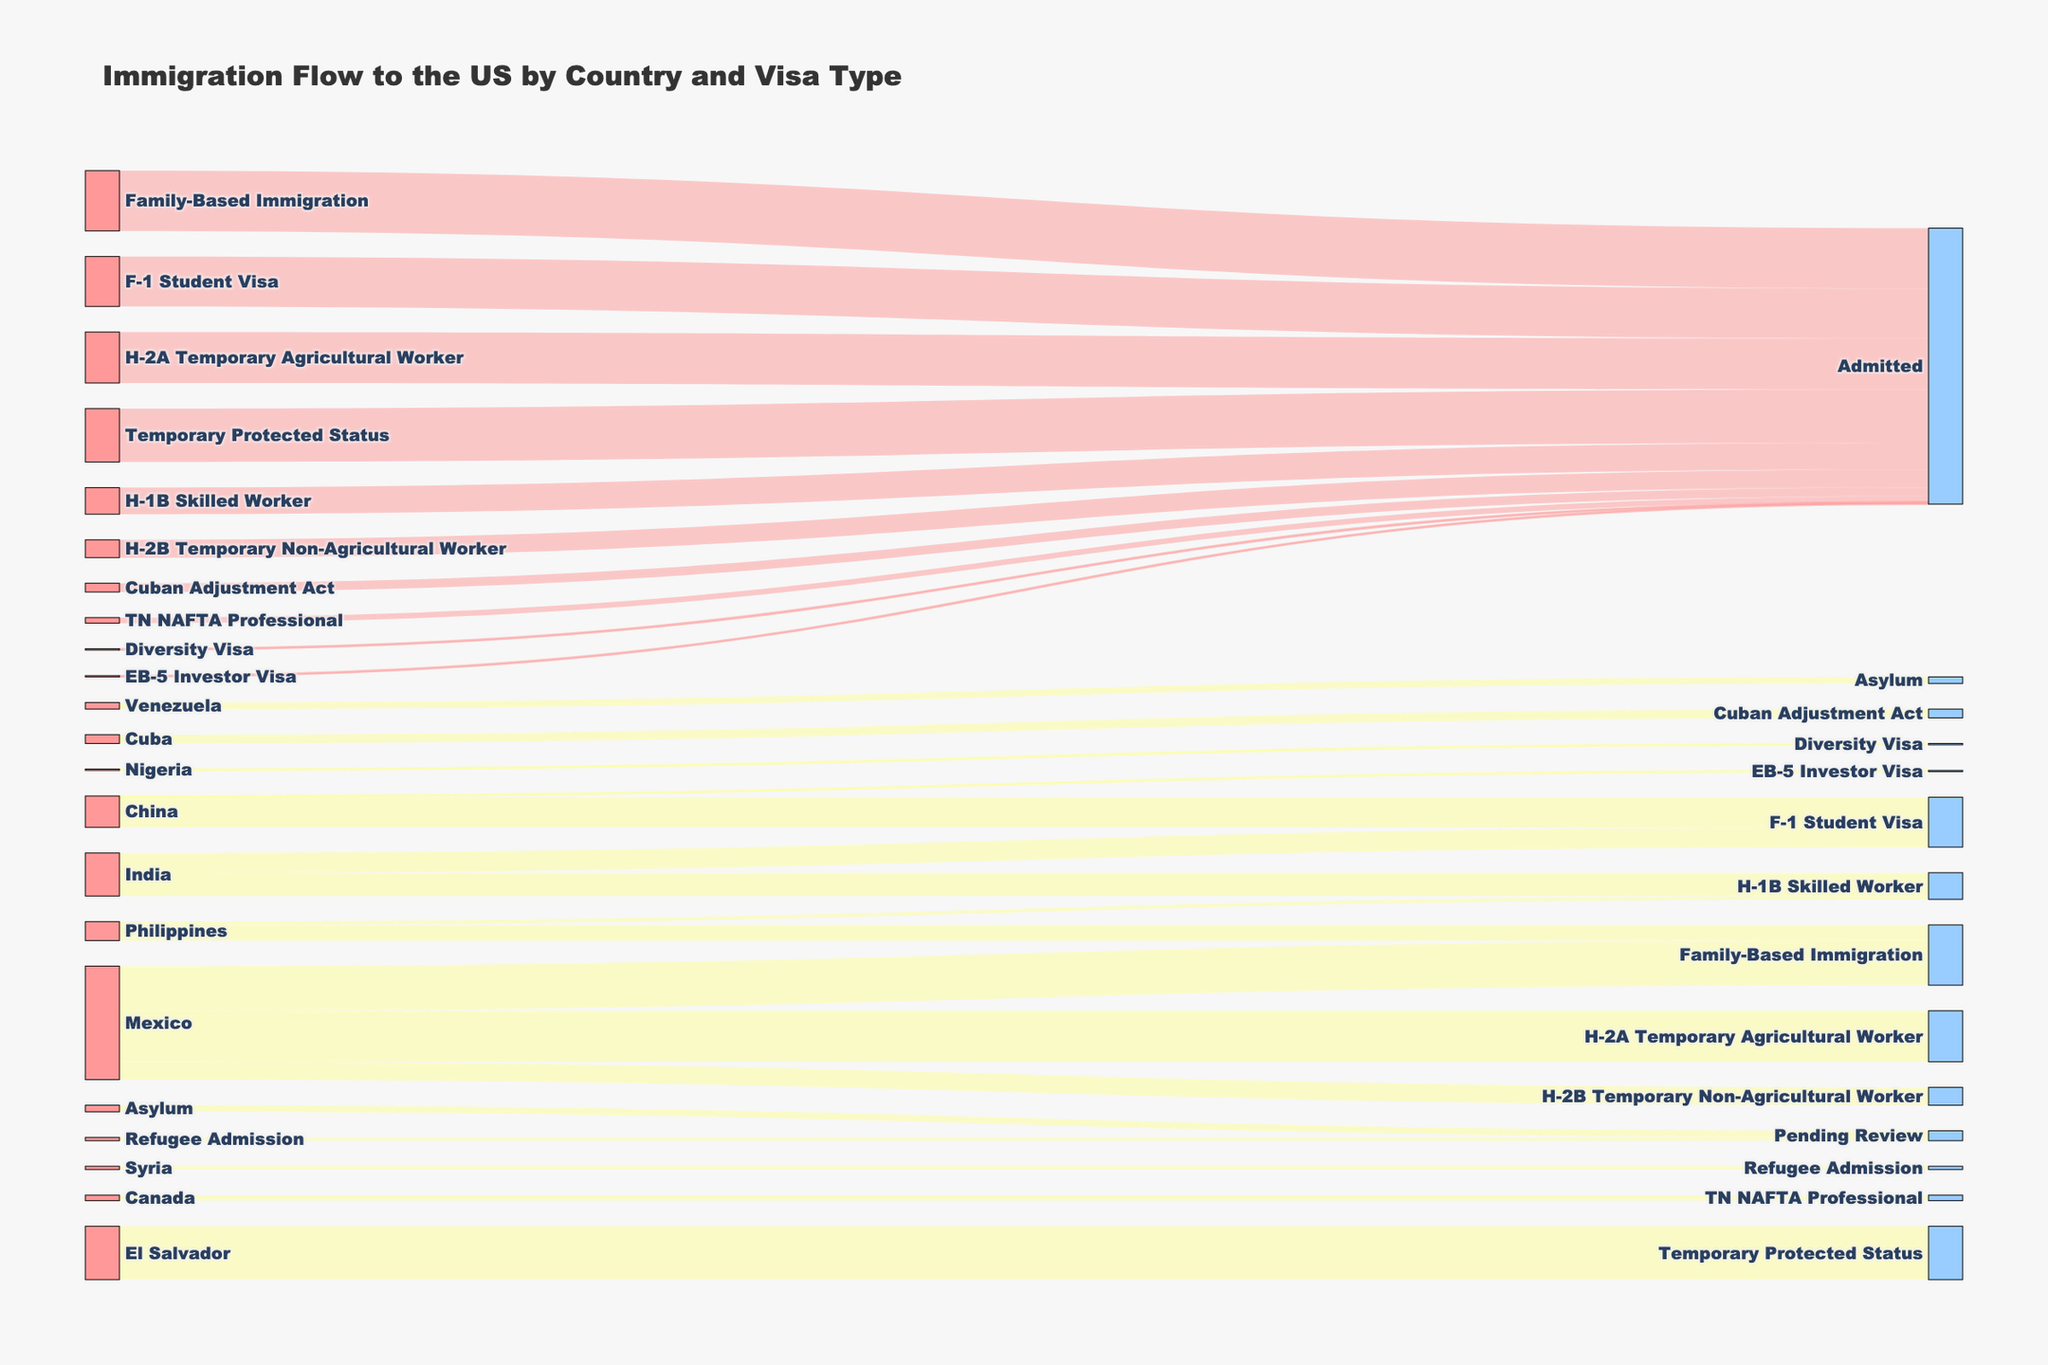What's the title of the figure? The title is usually displayed at the top of the figure. It provides a quick summary of what the chart represents.
Answer: Immigration Flow to the US by Country and Visa Type Which country has the highest number of H-2A Temporary Agricultural Worker visas? Look for the "H-2A Temporary Agricultural Worker" label and trace back to the country with the largest flow value associated with it.
Answer: Mexico From which country does Family-Based Immigration contribute the most? Find the "Family-Based Immigration" label, and check the originating flows to see which country has the highest number.
Answer: Mexico Compare the number of H-2B Temporary Non-Agricultural Worker visas from Mexico and the number of F-1 Student Visas from China. Which is higher? Find the values associated with "H-2B Temporary Non-Agricultural Worker" from Mexico and "F-1 Student Visa" from China, then compare them.
Answer: F-1 Student Visa from China What is the total number of admissions for all visa types combined? Sum all the values directed towards the "Admitted" nodes. These include H-2A, H-2B, Family-Based Immigration, H-1B, F-1, EB-5, Temporary Protected Status, Cuban Adjustment Act, Diversity Visa, TN NAFTA Professional.
Answer: 977,500 How many more people were admitted under H-2A Temporary Agricultural Worker visas than H-1B Skilled Worker visas? Subtract the number of H-1B Skilled Worker admissions from the H-2A Temporary Agricultural Worker admissions. H-2A: 186,000, H-1B: 97,000
Answer: 89,000 How many countries contribute to the F-1 Student Visa category? Look at the F-1 Student Visa label and count the number of originating countries connected to it.
Answer: 2 (India and China) Which visa type related to Mexico has the smallest number of admissions? Identify all visa types associated with Mexico and compare their admitted values.
Answer: H-2B Temporary Non-Agricultural Worker Are there more people admitted from the Philippines under Family-Based Immigration or from Nigeria under Diversity Visa? Compare the admission values for "Family-Based Immigration" from the Philippines and "Diversity Visa" from Nigeria.
Answer: Family-Based Immigration from the Philippines How many individuals are pending review for Asylum and Refugee Admission combined? Sum the values for Asylum and Refugee Admission which are marked as pending review. Asylum: 24,000, Refugee Admission: 12,000
Answer: 36,000 Which visa type associated with India has higher admissions: H-1B Skilled Worker or F-1 Student Visa? Compare the admissions values for H-1B Skilled Worker and F-1 Student Visa linked to India.
Answer: F-1 Student Visa 